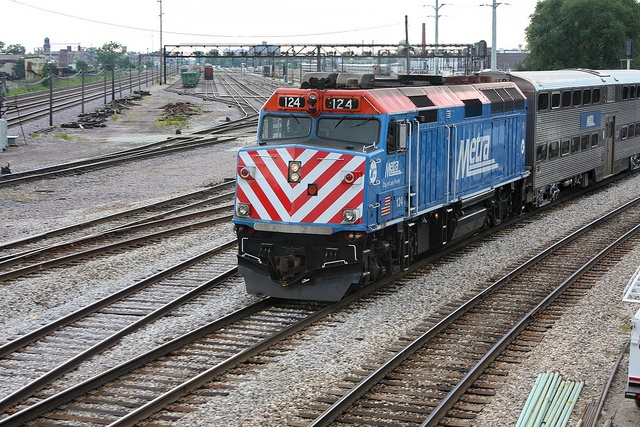Describe the objects in this image and their specific colors. I can see train in white, black, gray, blue, and lightgray tones and train in white, gray, purple, black, and darkgray tones in this image. 